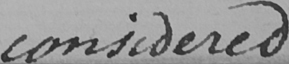Please provide the text content of this handwritten line. considered 